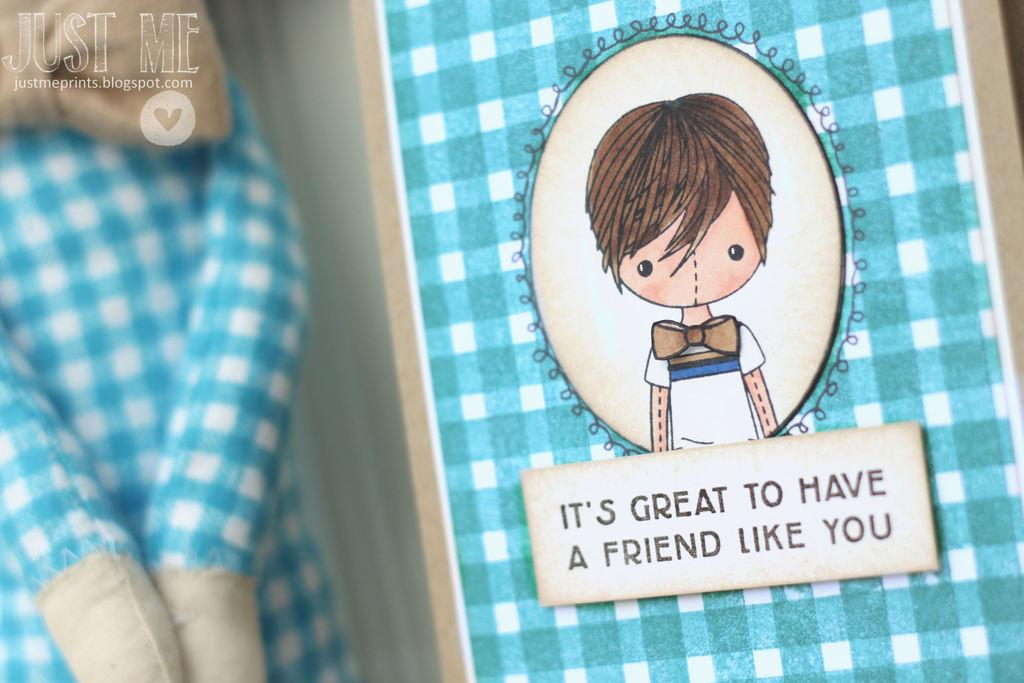What type of visual content is located on the right side of the image? There is a cartoon on the right side of the image. Is there any accompanying information with the cartoon? Yes, there is text associated with the cartoon. What can be seen on the left side of the image? There is a doll on the left side of the image. Can you hear the guitar playing in the image? There is no guitar present in the image, so it is not possible to hear it playing. 